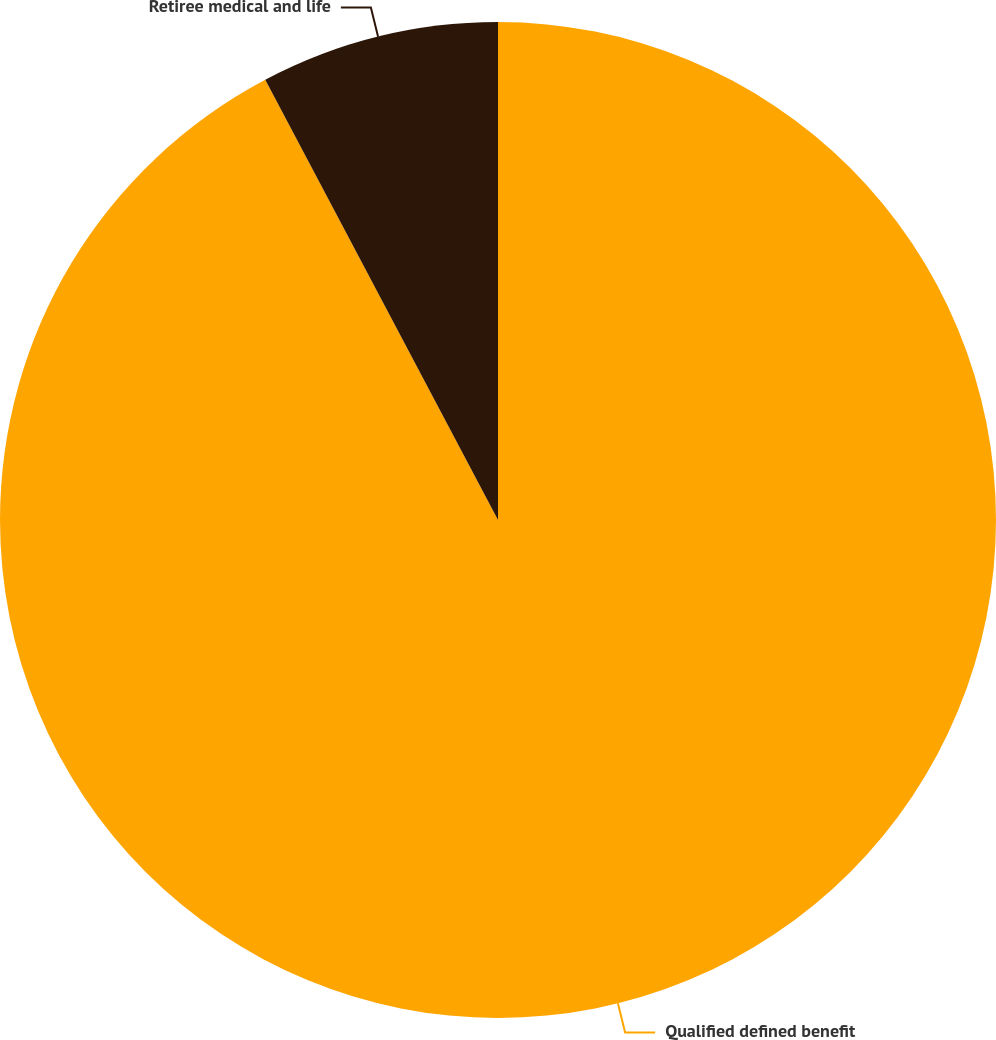Convert chart. <chart><loc_0><loc_0><loc_500><loc_500><pie_chart><fcel>Qualified defined benefit<fcel>Retiree medical and life<nl><fcel>92.26%<fcel>7.74%<nl></chart> 